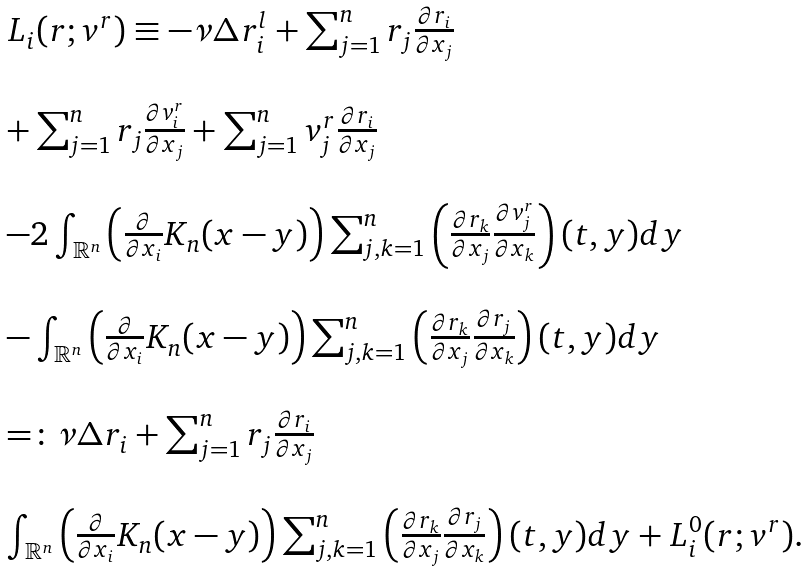Convert formula to latex. <formula><loc_0><loc_0><loc_500><loc_500>\begin{array} { l l } L _ { i } ( r ; v ^ { r } ) \equiv - \nu \Delta r ^ { l } _ { i } + \sum _ { j = 1 } ^ { n } r _ { j } \frac { \partial r _ { i } } { \partial x _ { j } } \\ \\ + \sum _ { j = 1 } ^ { n } r _ { j } \frac { \partial v ^ { r } _ { i } } { \partial x _ { j } } + \sum _ { j = 1 } ^ { n } v ^ { r } _ { j } \frac { \partial r _ { i } } { \partial x _ { j } } \\ \\ - 2 \int _ { { \mathbb { R } } ^ { n } } \left ( \frac { \partial } { \partial x _ { i } } K _ { n } ( x - y ) \right ) \sum _ { j , k = 1 } ^ { n } \left ( \frac { \partial r _ { k } } { \partial x _ { j } } \frac { \partial v ^ { r } _ { j } } { \partial x _ { k } } \right ) ( t , y ) d y \\ \\ - \int _ { { \mathbb { R } } ^ { n } } \left ( \frac { \partial } { \partial x _ { i } } K _ { n } ( x - y ) \right ) \sum _ { j , k = 1 } ^ { n } \left ( \frac { \partial r _ { k } } { \partial x _ { j } } \frac { \partial r _ { j } } { \partial x _ { k } } \right ) ( t , y ) d y \\ \\ = \colon \nu \Delta r _ { i } + \sum _ { j = 1 } ^ { n } r _ { j } \frac { \partial r _ { i } } { \partial x _ { j } } \\ \\ \int _ { { \mathbb { R } } ^ { n } } \left ( \frac { \partial } { \partial x _ { i } } K _ { n } ( x - y ) \right ) \sum _ { j , k = 1 } ^ { n } \left ( \frac { \partial r _ { k } } { \partial x _ { j } } \frac { \partial r _ { j } } { \partial x _ { k } } \right ) ( t , y ) d y + L ^ { 0 } _ { i } ( r ; v ^ { r } ) . \end{array}</formula> 